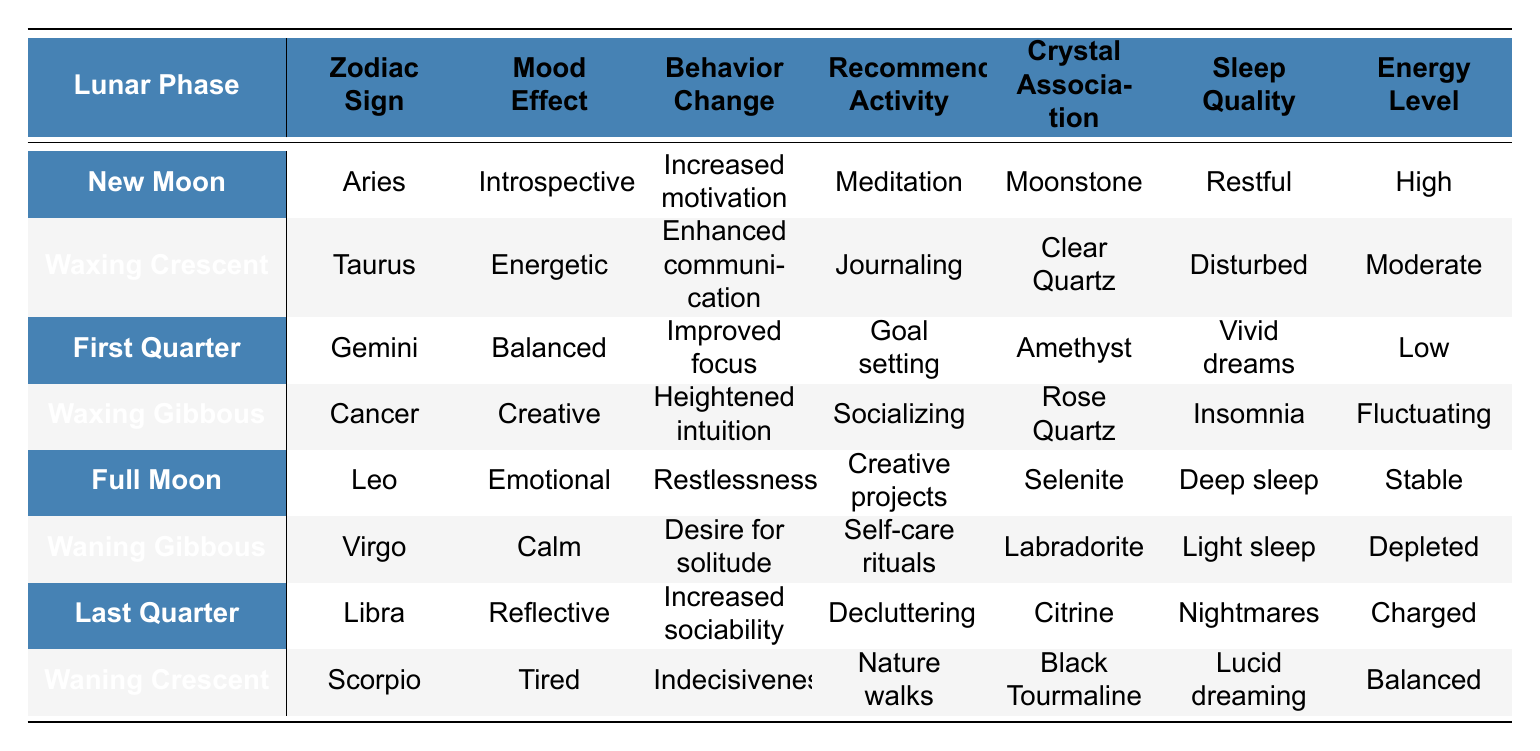What mood effect is associated with the New Moon phase? The table shows that the mood effect associated with the New Moon phase is "Introspective".
Answer: Introspective Which zodiac sign corresponds with the Full Moon? Referring to the table, the zodiac sign that corresponds with the Full Moon is Leo.
Answer: Leo What recommended activity is suggested during the Waning Gibbous phase? According to the table, the recommended activity for the Waning Gibbous phase is "Self-care rituals".
Answer: Self-care rituals Is the sleep quality during the Waxing Crescent phase restful? The table indicates that the sleep quality during the Waxing Crescent phase is "Disturbed", so the answer is no.
Answer: No What mood effects are associated with both the New Moon and the First Quarter phases? The New Moon is associated with "Introspective", and the First Quarter is associated with "Balanced". Both must be acknowledged, so the comparison is direct.
Answer: Introspective and Balanced How many lunar phases are associated with a low energy level? The energies listed for the lunar phases are "Low", "Depleted", "Disturbed", and "Fluctuating", with "Low" explicitly representing one energy level. Only one phase (First Quarter) directly corresponds with low energy based on the table.
Answer: 1 Does the Last Quarter phase promote a desire for solitude? The Last Quarter phase is linked to "Increased sociability", thus implying that it does not promote solitude.
Answer: No What is the average mood effect for phases associated with emotional states (like Full Moon)? The only emotional mood effect mentioned is "Emotional" from the Full Moon. As such, there isn't more data to average. Therefore, it is solely "Emotional".
Answer: Emotional Which energy levels are linked to the Waning Crescent phase? The table specifies the energy level during the Waning Crescent phase as "Balanced".
Answer: Balanced List the recommended activities for the phases where mood effects are reflective or calm. The table shows "Self-care rituals" for Waning Gibbous and "Meditation" for the New Moon, which fits this criterion of calmness or reflection.
Answer: Self-care rituals, Meditation 